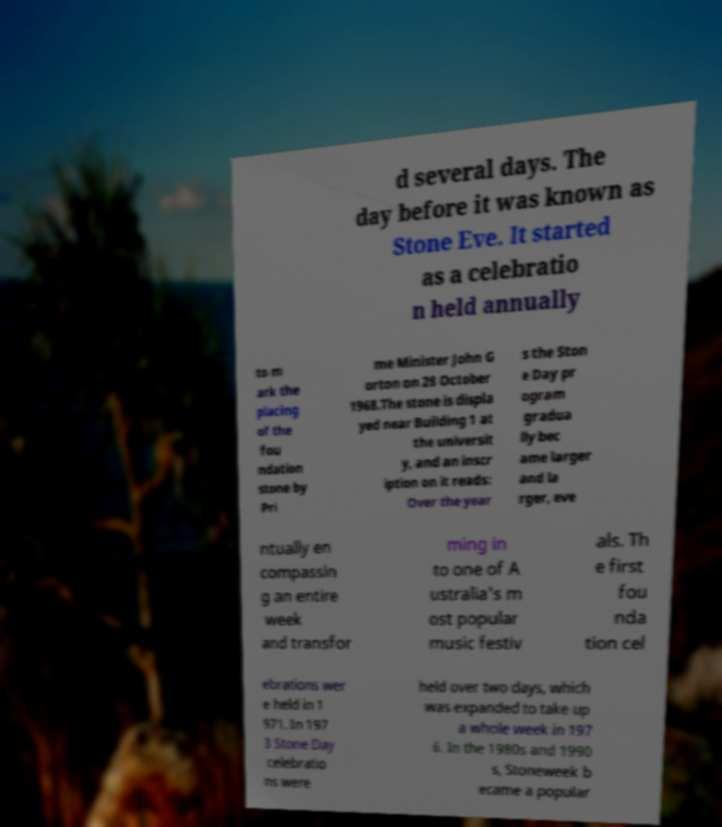Can you read and provide the text displayed in the image?This photo seems to have some interesting text. Can you extract and type it out for me? d several days. The day before it was known as Stone Eve. It started as a celebratio n held annually to m ark the placing of the fou ndation stone by Pri me Minister John G orton on 28 October 1968.The stone is displa yed near Building 1 at the universit y, and an inscr iption on it reads: Over the year s the Ston e Day pr ogram gradua lly bec ame larger and la rger, eve ntually en compassin g an entire week and transfor ming in to one of A ustralia's m ost popular music festiv als. Th e first fou nda tion cel ebrations wer e held in 1 971. In 197 3 Stone Day celebratio ns were held over two days, which was expanded to take up a whole week in 197 6. In the 1980s and 1990 s, Stoneweek b ecame a popular 